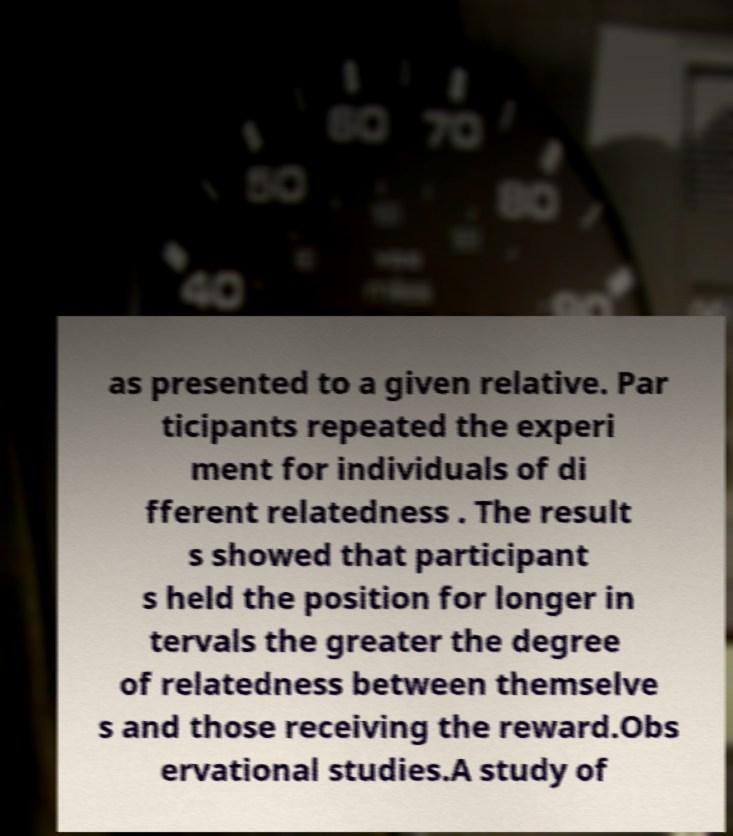Could you assist in decoding the text presented in this image and type it out clearly? as presented to a given relative. Par ticipants repeated the experi ment for individuals of di fferent relatedness . The result s showed that participant s held the position for longer in tervals the greater the degree of relatedness between themselve s and those receiving the reward.Obs ervational studies.A study of 